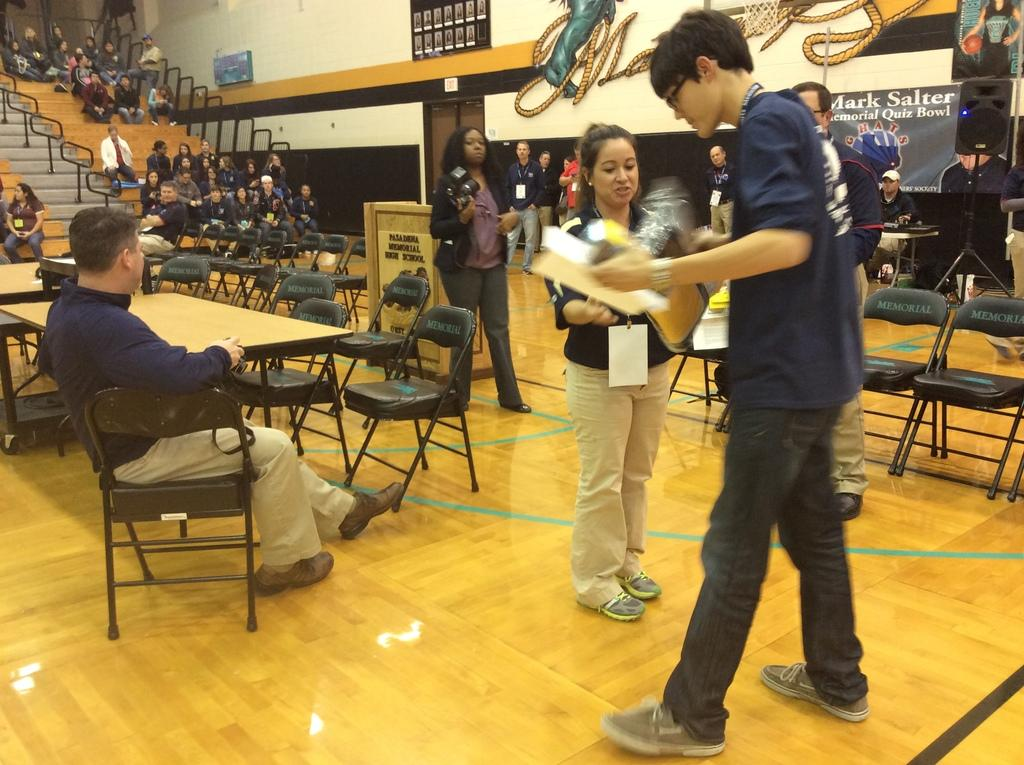What are the people in the image doing? There is a group of people standing and a group of people sitting in chairs in the image. What can be seen in the background of the image? There is a banner, a speaker, a chair, and a table in the background of the image. What is the rhythm of the hour in the image? There is no reference to time or rhythm in the image, so this question cannot be answered definitively. 